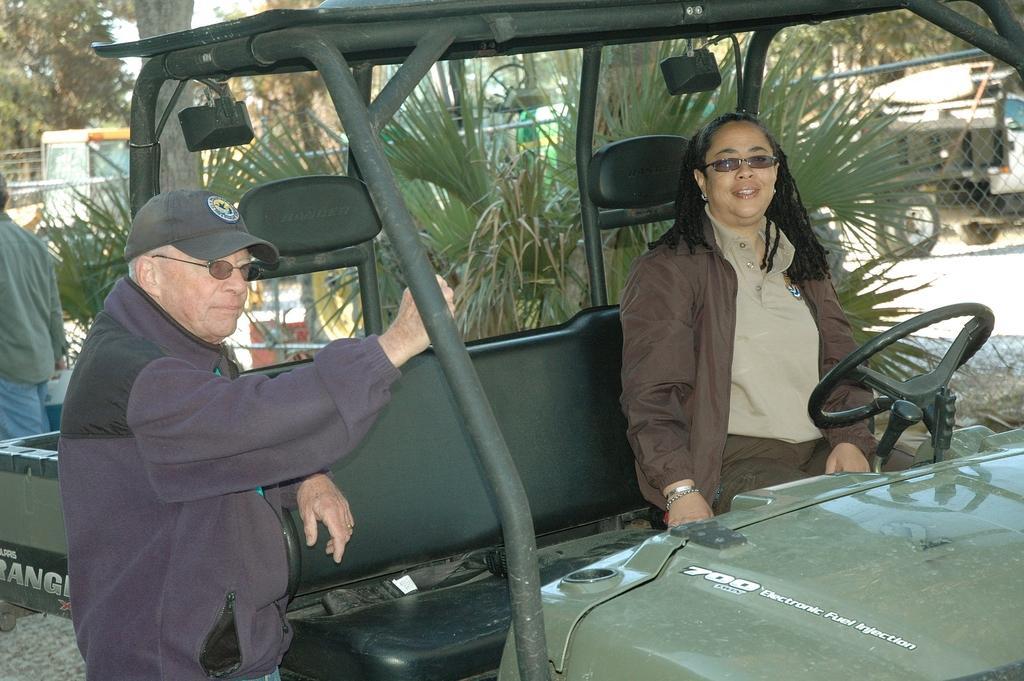Please provide a concise description of this image. In this image, there are three persons wearing colorful clothes. These two persons are wearing sunglasses. This person sitting on the jeep. This person wearing cap on his head. There is a plant behind this person. This person holding a can. 